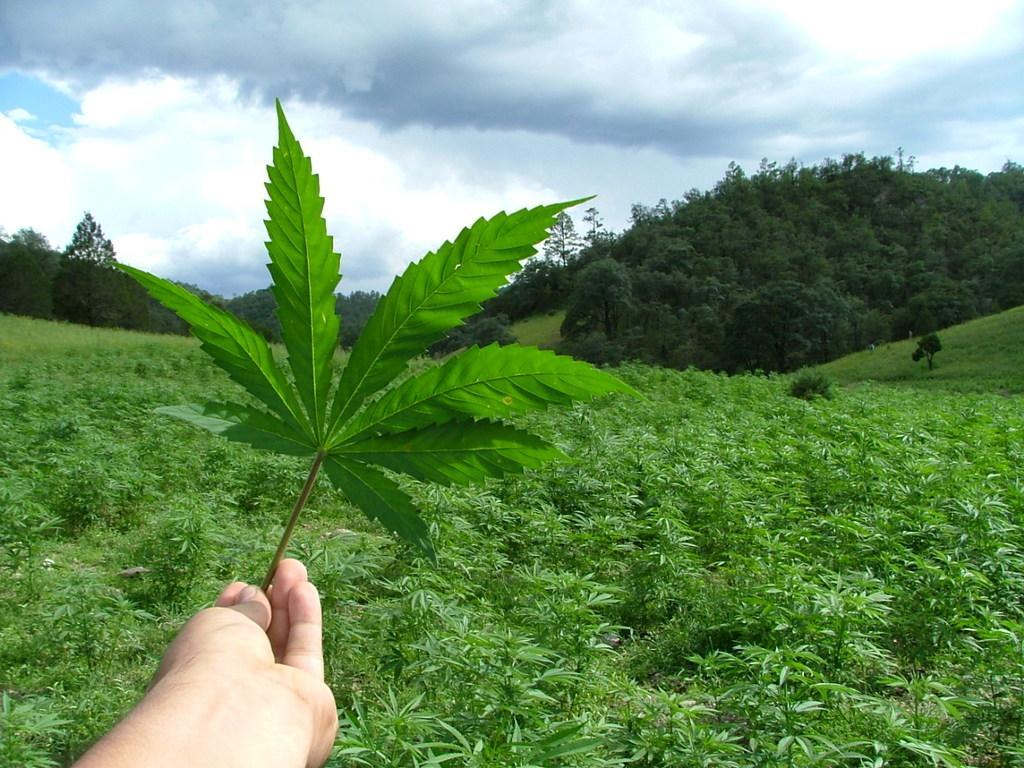Could you give a brief overview of what you see in this image? In the picture I can see a plant in a person's hand. In the background I can see the sky. 